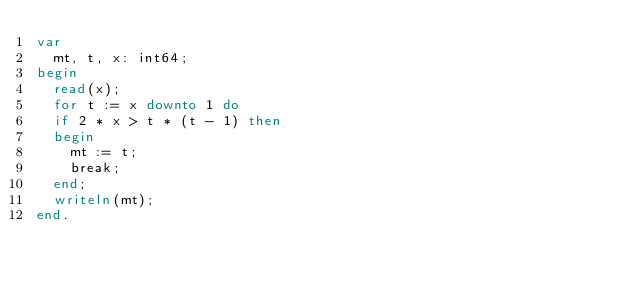Convert code to text. <code><loc_0><loc_0><loc_500><loc_500><_Pascal_>var
  mt, t, x: int64;
begin
  read(x);
  for t := x downto 1 do
  if 2 * x > t * (t - 1) then
  begin
    mt := t;
    break;
  end;
  writeln(mt);
end.</code> 